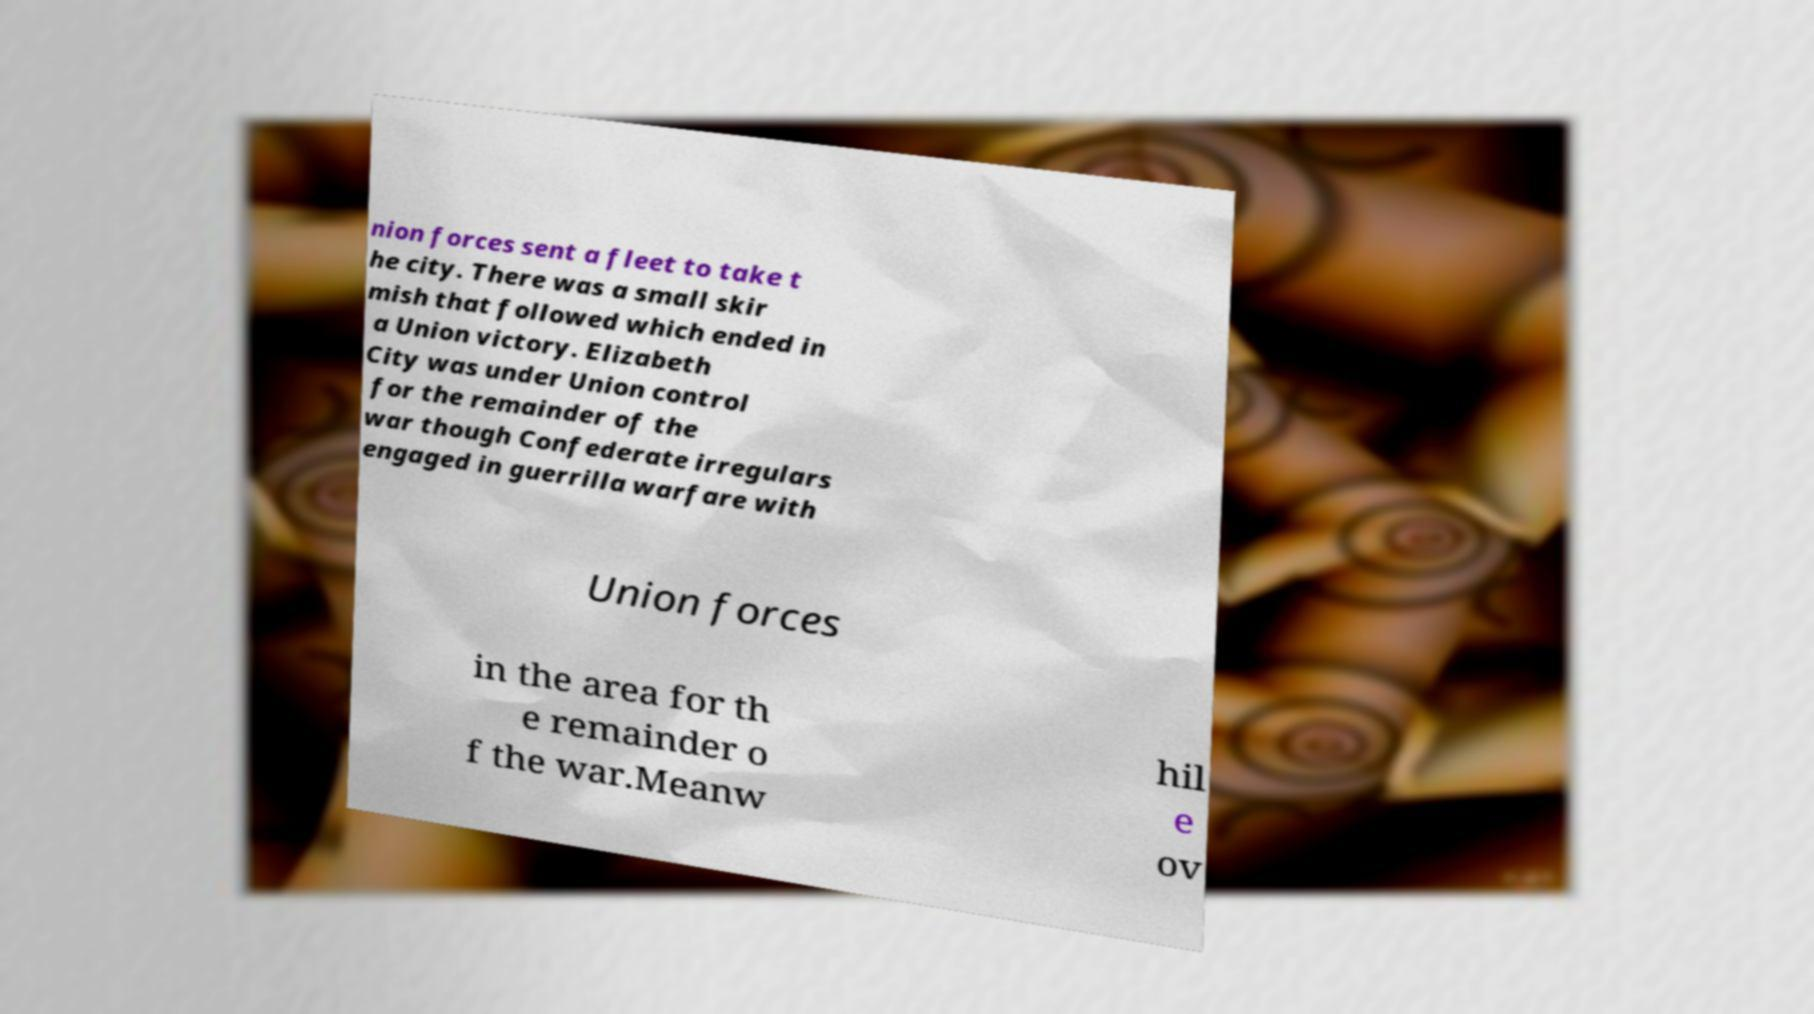Could you extract and type out the text from this image? nion forces sent a fleet to take t he city. There was a small skir mish that followed which ended in a Union victory. Elizabeth City was under Union control for the remainder of the war though Confederate irregulars engaged in guerrilla warfare with Union forces in the area for th e remainder o f the war.Meanw hil e ov 